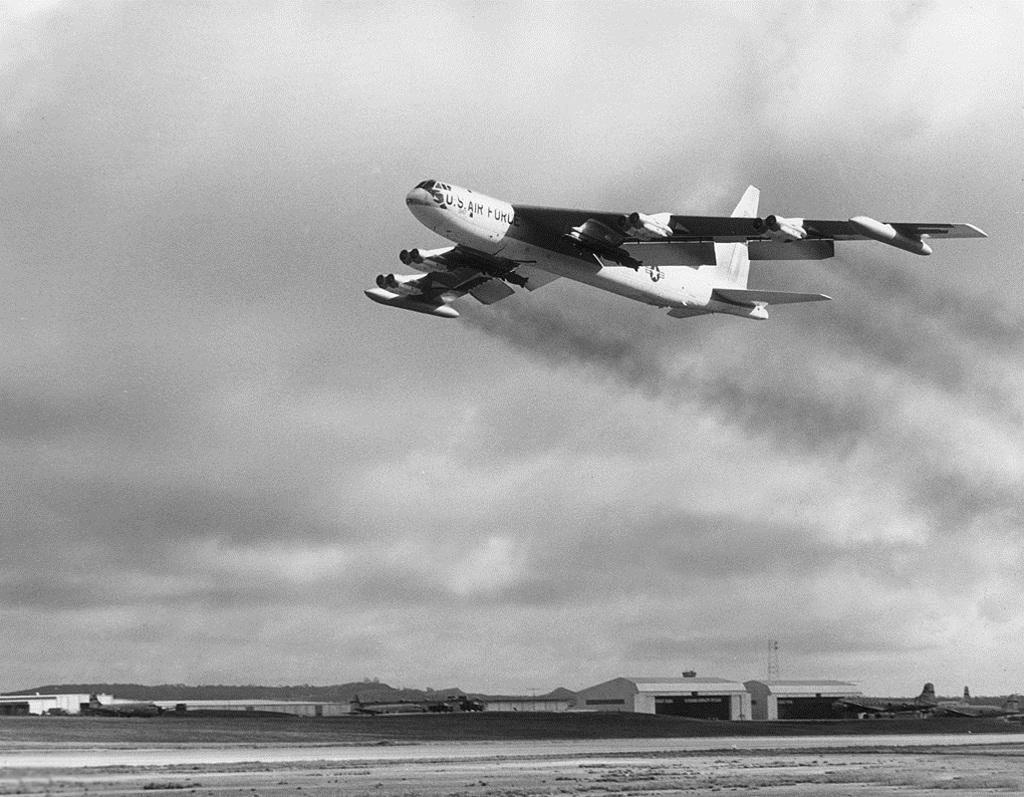Provide a one-sentence caption for the provided image. A large US Air Force Jet is flying over an airfield. 